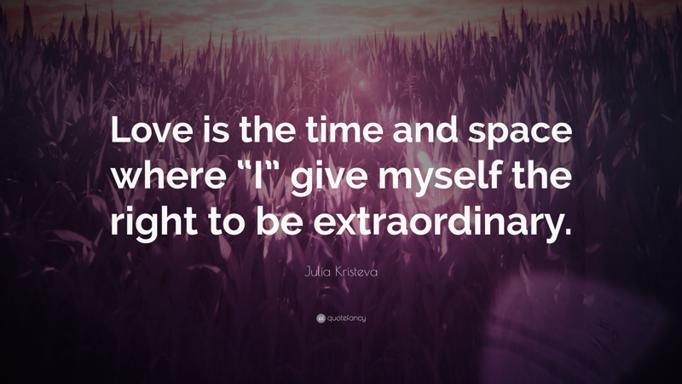Can you describe the visual aspect of the image? The image features a vibrant purple and pink sky that casts a gentle glow across a dense field of silhouetted grass, creating a serene and somewhat mystical atmosphere. This backdrop beautifully complements the profound quote by Julia Kristeva, adding a dreamy quality to the message about love and individuality. 